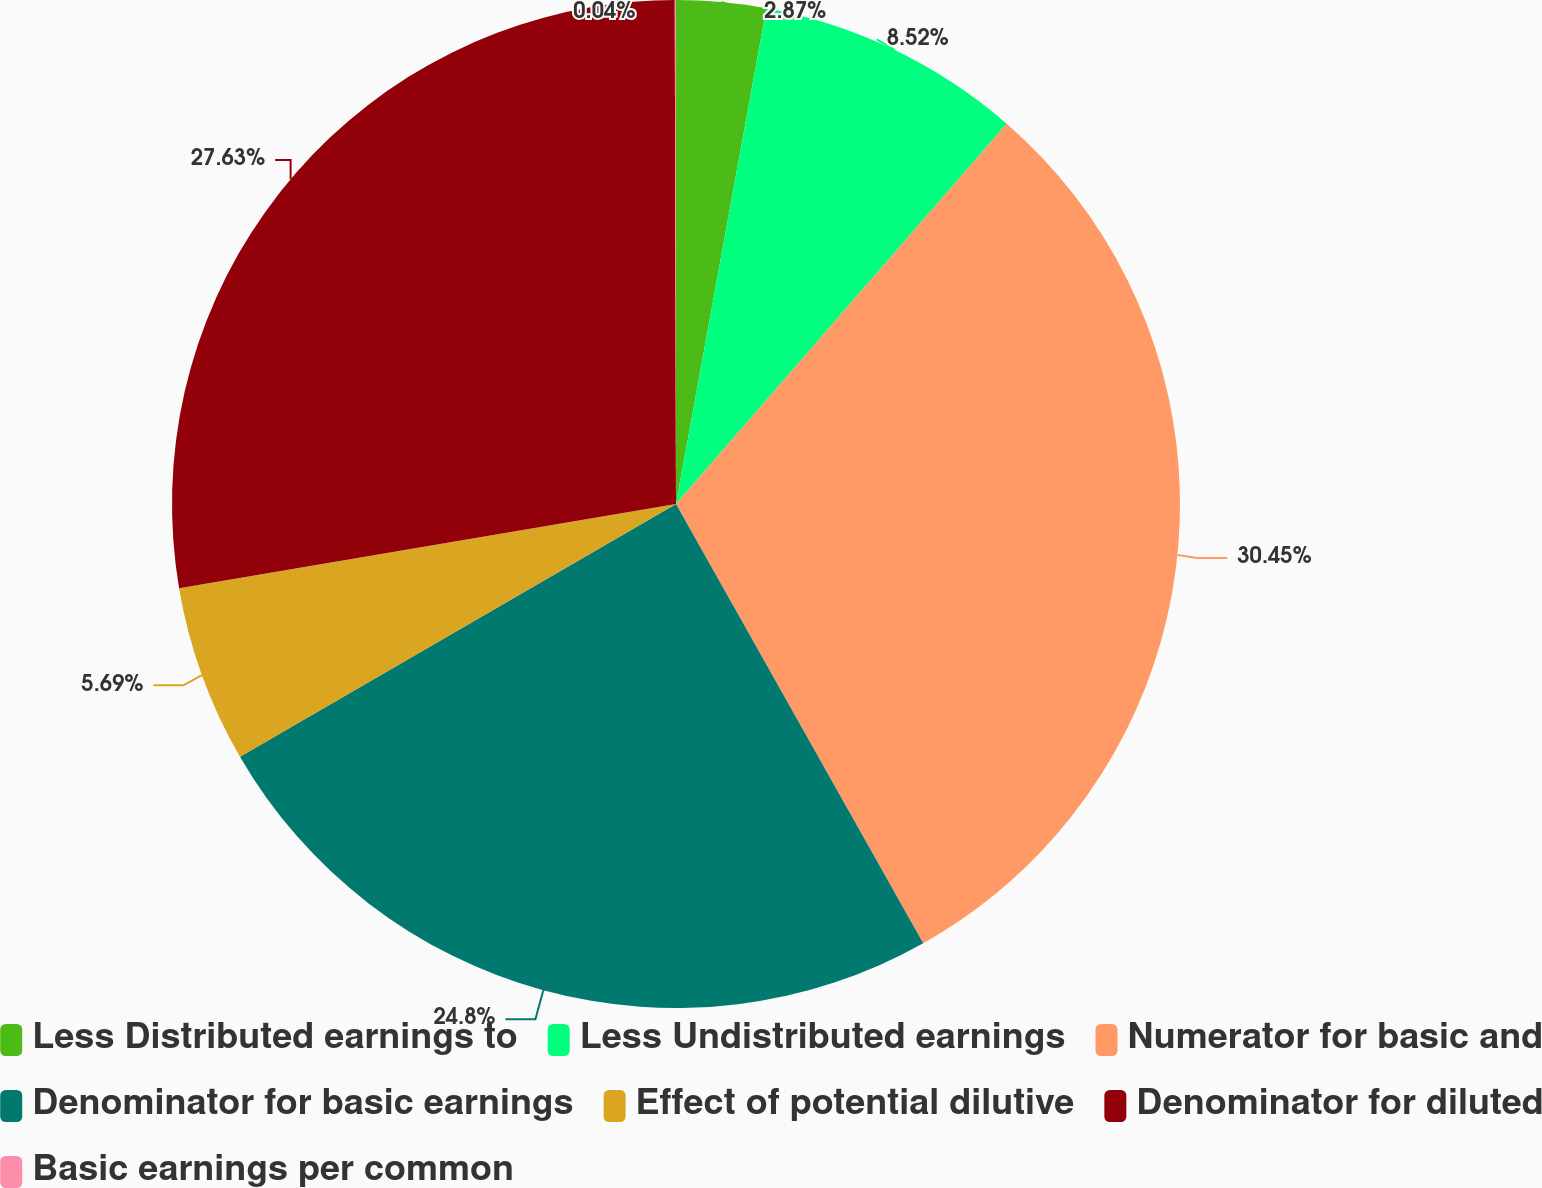<chart> <loc_0><loc_0><loc_500><loc_500><pie_chart><fcel>Less Distributed earnings to<fcel>Less Undistributed earnings<fcel>Numerator for basic and<fcel>Denominator for basic earnings<fcel>Effect of potential dilutive<fcel>Denominator for diluted<fcel>Basic earnings per common<nl><fcel>2.87%<fcel>8.52%<fcel>30.45%<fcel>24.8%<fcel>5.69%<fcel>27.63%<fcel>0.04%<nl></chart> 